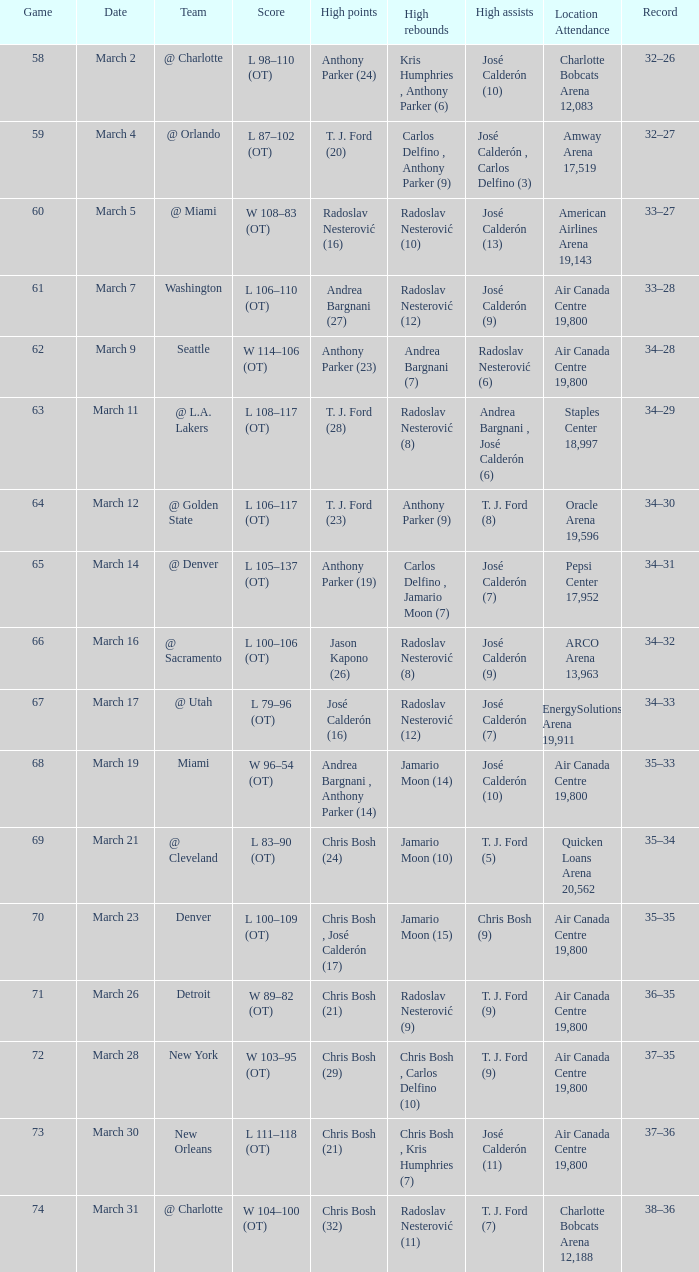In what game sequence did radoslav nesterović record 8 elevated rebounds and josé calderón contribute 9 peak assists? 1.0. 